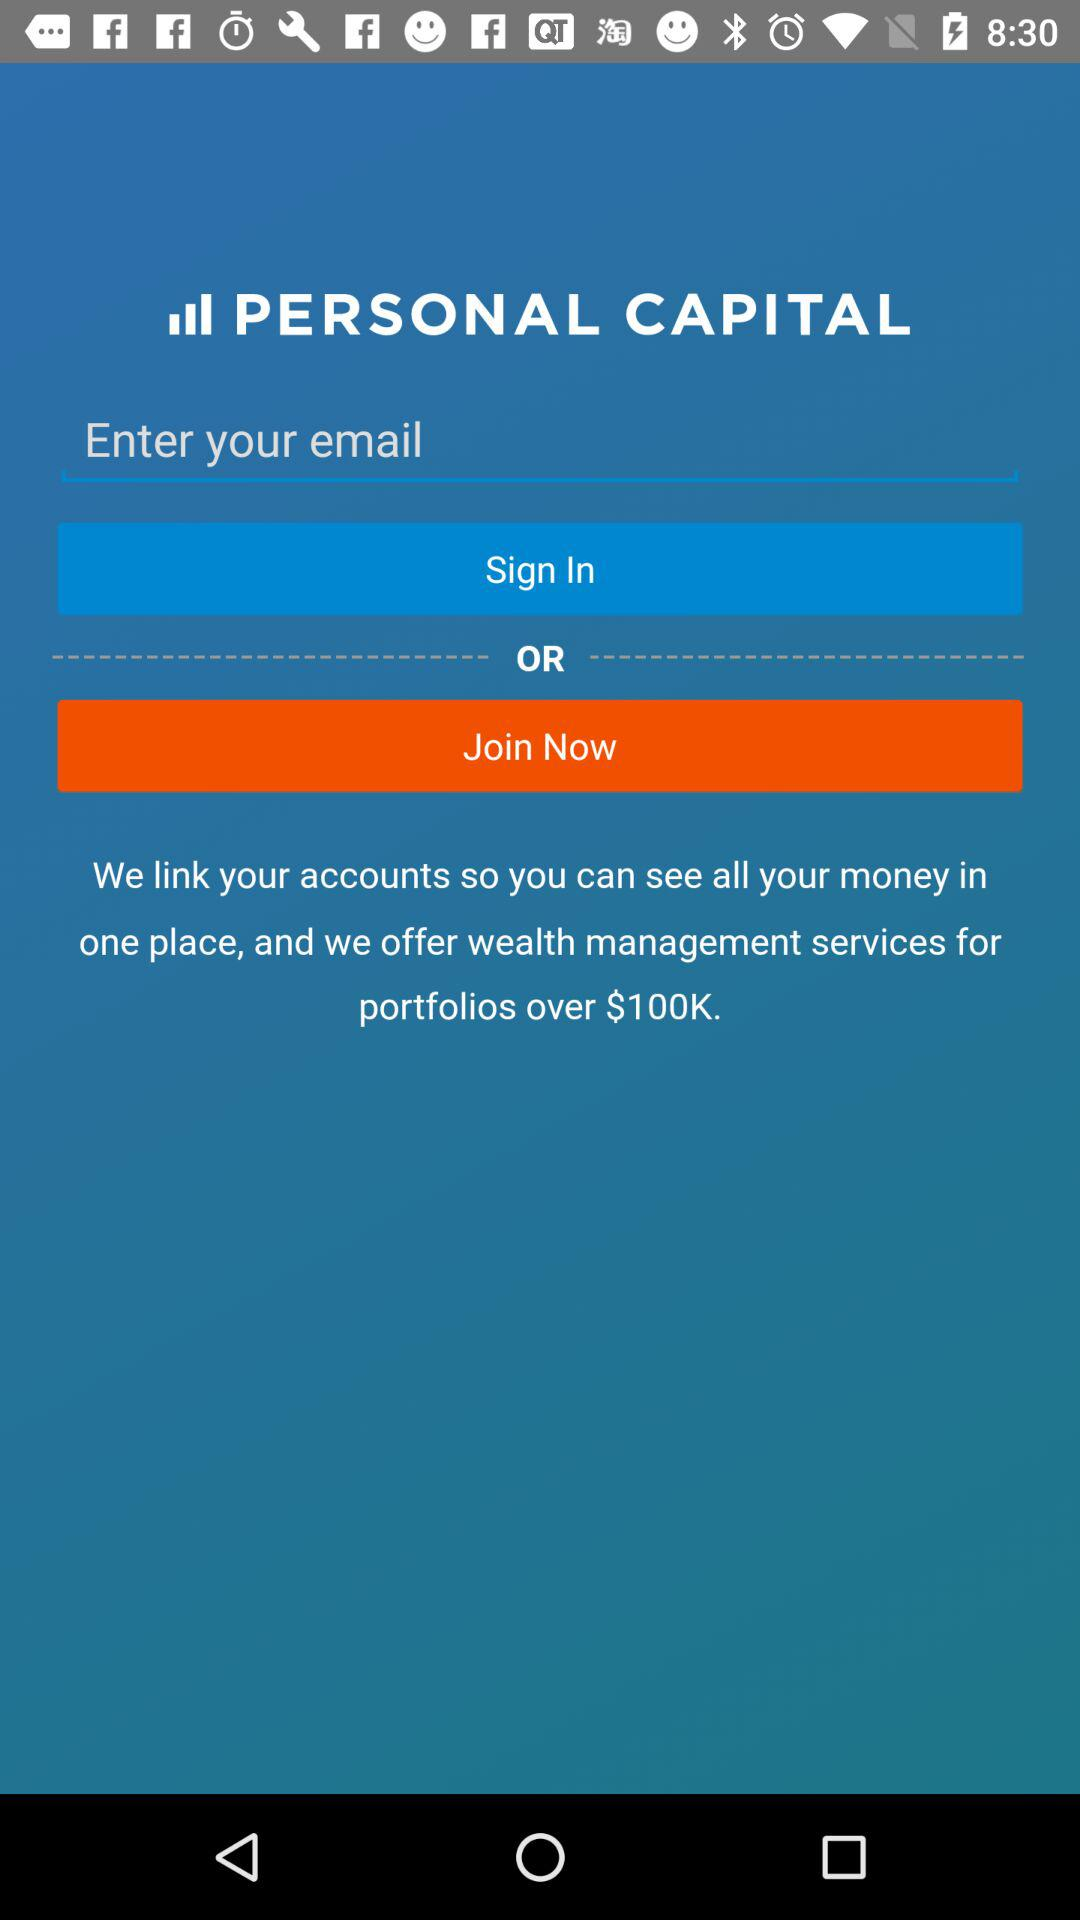How much money do you need in your portfolio to qualify for wealth management services?
Answer the question using a single word or phrase. $100K 